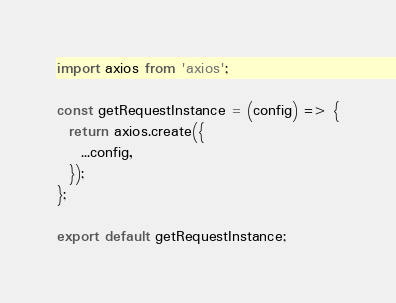<code> <loc_0><loc_0><loc_500><loc_500><_JavaScript_>import axios from 'axios';

const getRequestInstance = (config) => {
  return axios.create({
    ...config,
  });
};

export default getRequestInstance;
</code> 